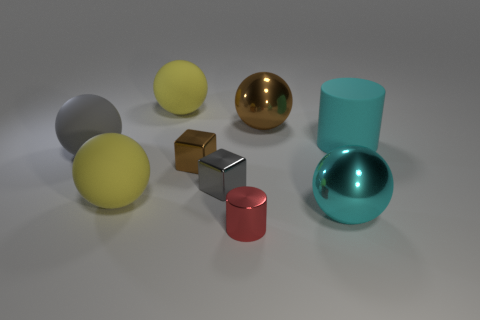Is there anything else of the same color as the tiny cylinder?
Offer a terse response. No. The gray matte thing has what shape?
Offer a very short reply. Sphere. Is the number of cyan shiny things that are behind the big cyan rubber cylinder less than the number of gray cylinders?
Keep it short and to the point. No. Are there any big cyan metallic objects that have the same shape as the big gray thing?
Your response must be concise. Yes. There is a brown shiny thing that is the same size as the gray cube; what is its shape?
Ensure brevity in your answer.  Cube. What number of things are either brown shiny balls or gray matte objects?
Keep it short and to the point. 2. Is there a small brown metal block?
Make the answer very short. Yes. Is the number of small red metallic objects less than the number of small purple balls?
Ensure brevity in your answer.  No. Are there any gray cubes of the same size as the brown block?
Your answer should be very brief. Yes. Do the gray metal object and the brown shiny object to the left of the brown ball have the same shape?
Your answer should be very brief. Yes. 